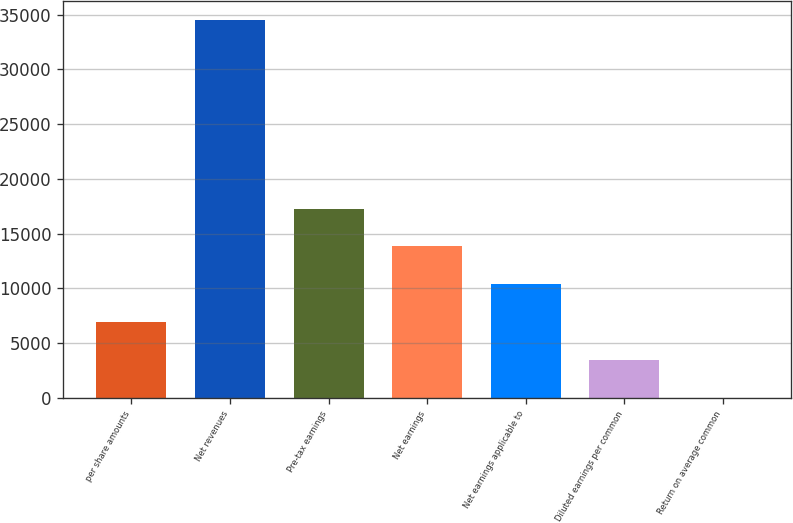<chart> <loc_0><loc_0><loc_500><loc_500><bar_chart><fcel>per share amounts<fcel>Net revenues<fcel>Pre-tax earnings<fcel>Net earnings<fcel>Net earnings applicable to<fcel>Diluted earnings per common<fcel>Return on average common<nl><fcel>6914.56<fcel>34528<fcel>17269.6<fcel>13817.9<fcel>10366.2<fcel>3462.88<fcel>11.2<nl></chart> 